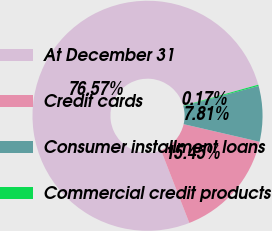Convert chart to OTSL. <chart><loc_0><loc_0><loc_500><loc_500><pie_chart><fcel>At December 31<fcel>Credit cards<fcel>Consumer installment loans<fcel>Commercial credit products<nl><fcel>76.57%<fcel>15.45%<fcel>7.81%<fcel>0.17%<nl></chart> 